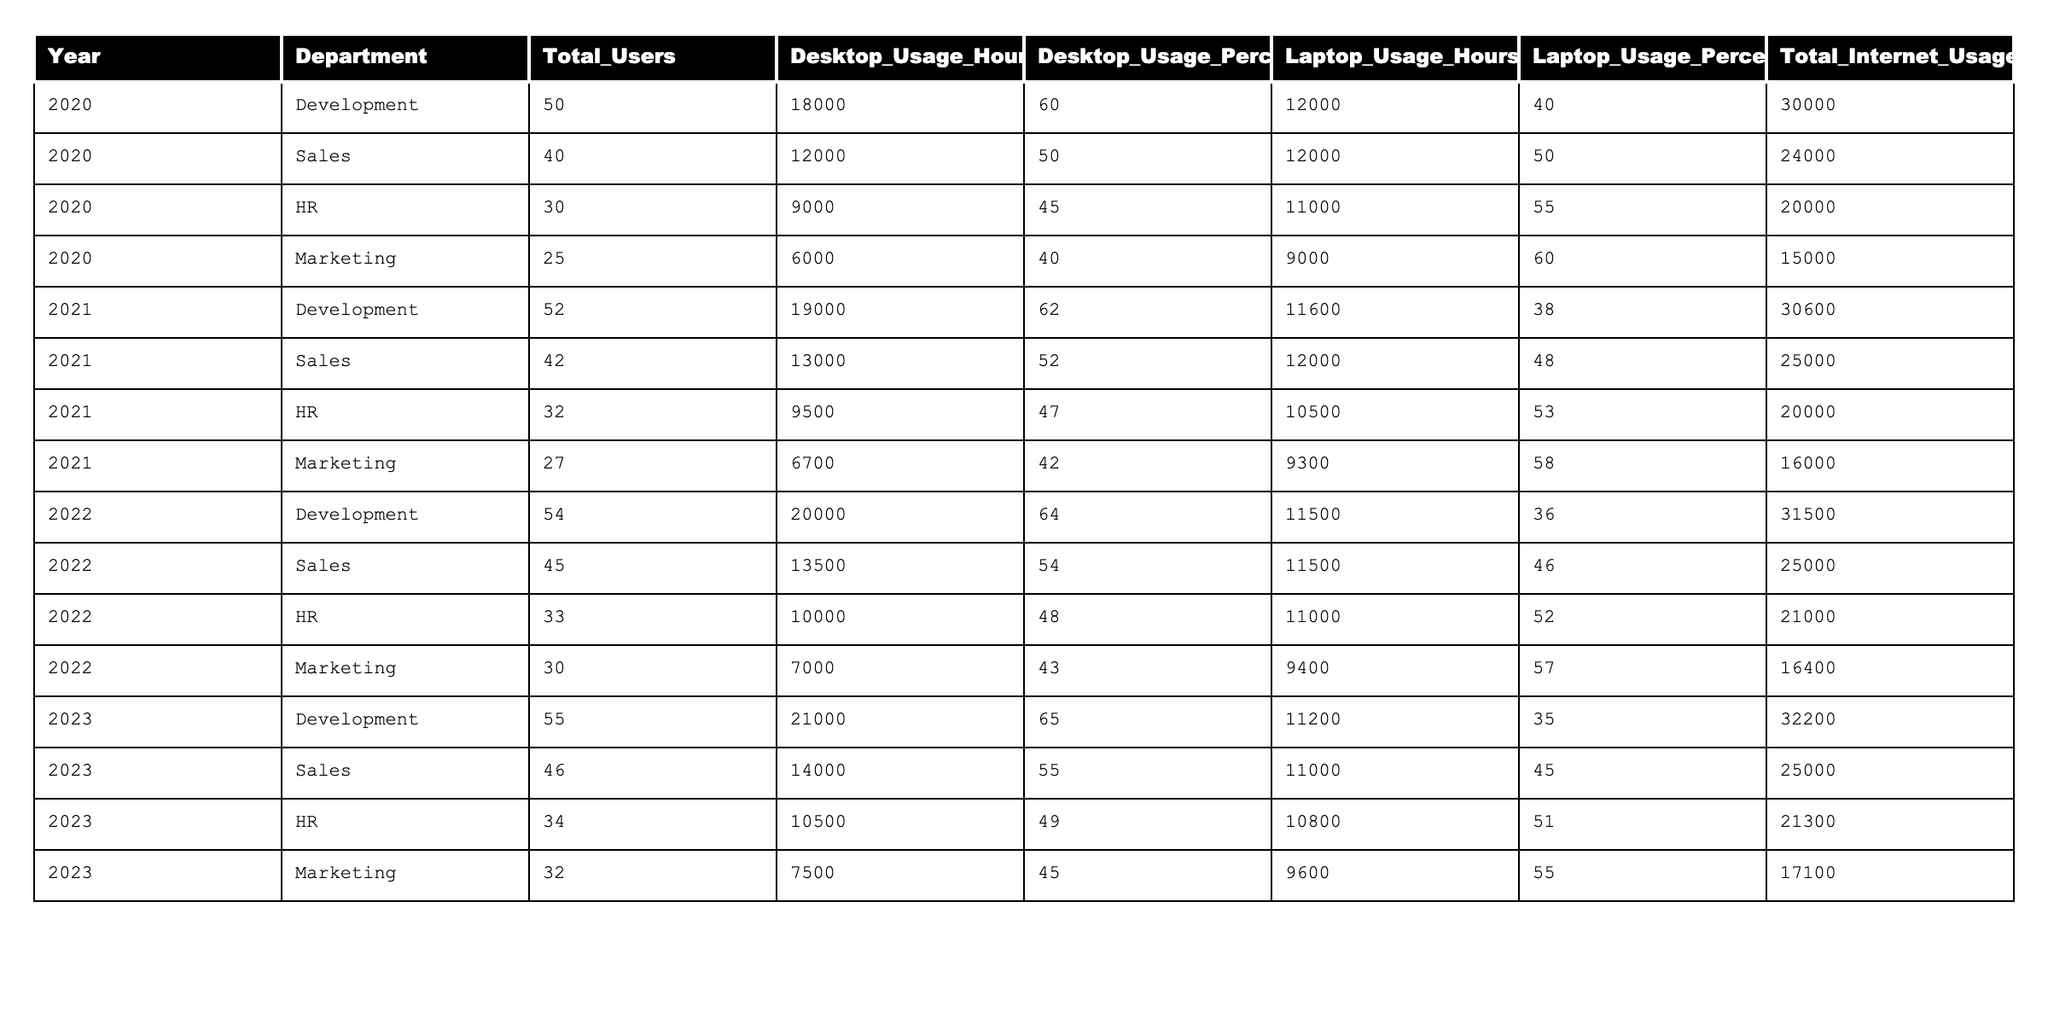What was the total desktop usage hours in the Development department for the year 2022? From the table, I can find the row for the Development department for the year 2022, which shows that the total desktop usage hours are 20,000.
Answer: 20000 Which department had the highest total internet usage hours in 2023? Looking at the last row in the table for 2023, the Development department has the highest total internet usage hours at 32,200.
Answer: Development What percentage of laptop usage hours does the HR department have in 2021 compared to its desktop usage hours? For 2021, the HR department had 10,500 laptop usage hours and 9,500 desktop usage hours. To calculate the percentage, divide laptop usage hours by the total usage hours (10,500 + 9,500) = 20,000. So, (10,500 / 20,000) x 100 = 52.5%.
Answer: 52.5% Did the total desktop usage hours in the Marketing department increase or decrease from 2020 to 2023? In 2020, Marketing had 6,000 desktop usage hours and in 2023 it had 7,500 desktop usage hours. Since 7,500 is greater than 6,000, it indicates an increase.
Answer: Increase What is the average desktop usage hours across all departments for the year 2021? To find the average, sum the desktop usage hours for each department in 2021: (19,000 + 13,000 + 9,500 + 6,700) = 48,200. Then divide by the number of departments (4), resulting in an average of 12,050.
Answer: 12050 Which year saw the highest percentage of laptop usage in the Sales department? Analyzing the Sales department across the years, the laptop usage percentages are: 50% (2020), 48% (2021), 46% (2022), and 45% (2023). The highest percentage is 50% in 2020.
Answer: 2020 How many more total users were there in Development in 2023 compared to 2020? In 2023, Development had 55 total users, and in 2020 it had 50. The difference is 55 - 50 = 5 additional users in 2023.
Answer: 5 What was the total laptop usage hours for the HR department in 2022? For 2022, the HR department's laptop usage hours are listed as 11,000 according to the table.
Answer: 11000 How does the total internet usage hours of Marketing in 2021 compare to that in 2022? The total internet usage hours for Marketing in 2021 were 16,000 and in 2022 it were 16,400. Comparing these, 16,400 is greater than 16,000, indicating an increase.
Answer: Increase What is the total desktop usage hours in the company for 2020? By summing the desktop usage hours across all departments for 2020: (18,000 + 12,000 + 9,000 + 6,000) = 45,000.
Answer: 45000 